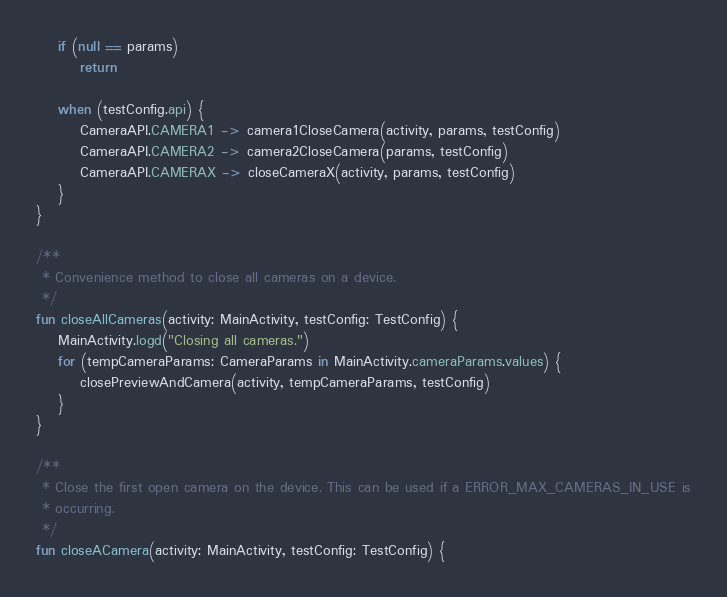<code> <loc_0><loc_0><loc_500><loc_500><_Kotlin_>    if (null == params)
        return

    when (testConfig.api) {
        CameraAPI.CAMERA1 -> camera1CloseCamera(activity, params, testConfig)
        CameraAPI.CAMERA2 -> camera2CloseCamera(params, testConfig)
        CameraAPI.CAMERAX -> closeCameraX(activity, params, testConfig)
    }
}

/**
 * Convenience method to close all cameras on a device.
 */
fun closeAllCameras(activity: MainActivity, testConfig: TestConfig) {
    MainActivity.logd("Closing all cameras.")
    for (tempCameraParams: CameraParams in MainActivity.cameraParams.values) {
        closePreviewAndCamera(activity, tempCameraParams, testConfig)
    }
}

/**
 * Close the first open camera on the device. This can be used if a ERROR_MAX_CAMERAS_IN_USE is
 * occurring.
 */
fun closeACamera(activity: MainActivity, testConfig: TestConfig) {</code> 